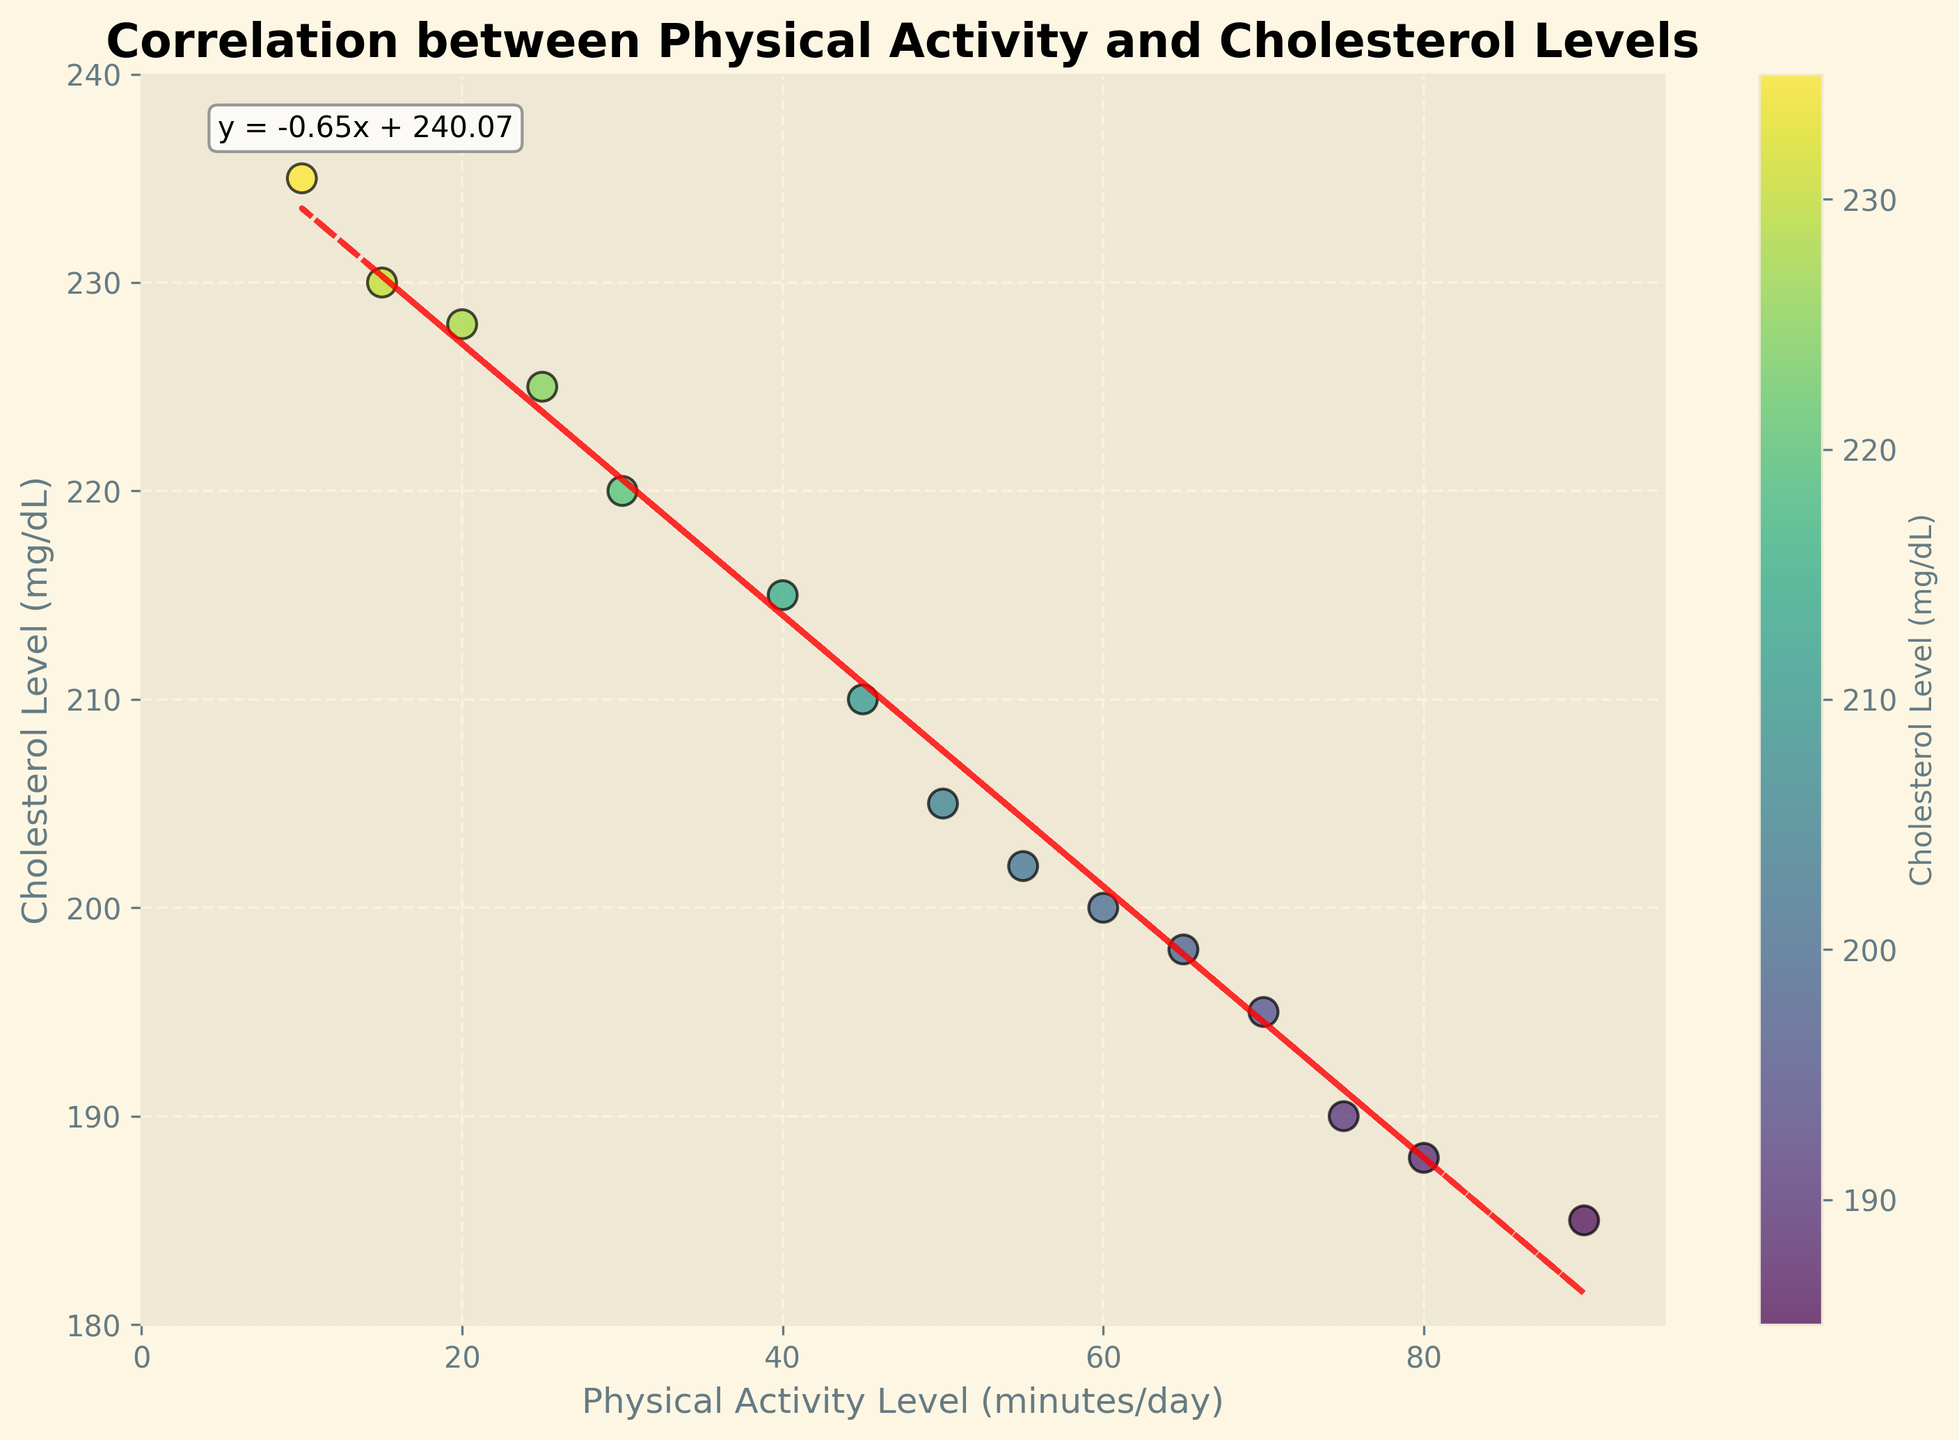What is the title of the figure? The title is located at the top of the figure and is written in a larger, bold font size. It provides a succinct summary of what the figure represents.
Answer: Correlation between Physical Activity and Cholesterol Levels What does the horizontal axis represent? The horizontal axis, also known as the x-axis, includes a label indicating what it measures. This information is found at the bottom of the figure.
Answer: Physical Activity Level (minutes/day) How many data points are there in the figure? The figure displays each data point as a dot. By counting these dots, you can determine the total number of data points.
Answer: 15 What is the equation of the trend line? The equation is annotated on the plot, usually in a text box. This represents the linear relationship modeled by the trend line.
Answer: y = -0.60x + 227.07 Based on the trend line, what can you infer about the relationship between physical activity levels and cholesterol levels? The trend line's slope indicates the direction and rate of change. A negative slope suggests that as the physical activity level increases, the cholesterol level tends to decrease.
Answer: Inverse relationship What is the cholesterol level for a physical activity level of 50 minutes/day as per the trend line? Substitute x = 50 into the trend line equation y = -0.60x + 227.07 to find y. This represents the cholesterol level.
Answer: 197.07 mg/dL Which data point represents the highest cholesterol level, and what is its corresponding physical activity level? Identify the highest point on the y-axis and then look downward to find its corresponding x-value.
Answer: 10, 235 mg/dL What is the range of physical activity levels shown in the figure? Determine the minimum and maximum values on the x-axis, then calculate the difference.
Answer: 80 minutes/day How does the scatter plot visually indicate different cholesterol levels? The color bar on the right of the plot shows a gradient indicating cholesterol levels, which correspond to the colors of the data points.
Answer: Different colors Do any points fall exactly on the trend line? Visually inspect the scatter plot to see if any dots are precisely on the red dashed line representing the trend line.
Answer: No 